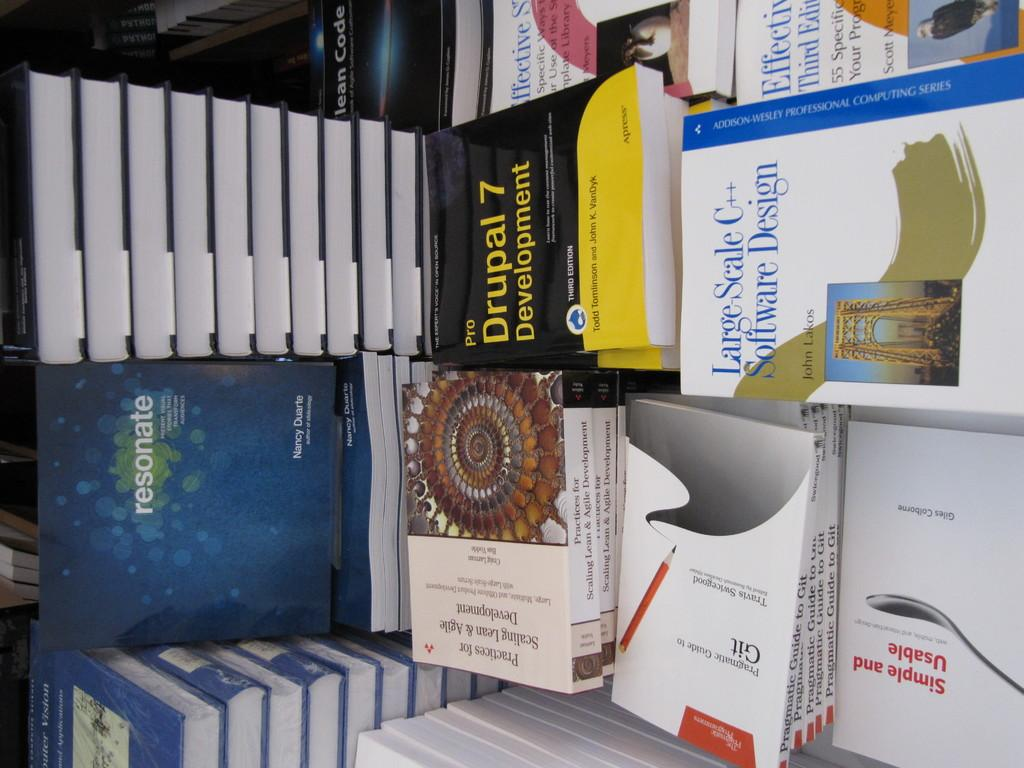Provide a one-sentence caption for the provided image. A table with a variety of book including Large Scale C++. 